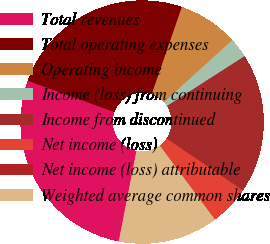Convert chart. <chart><loc_0><loc_0><loc_500><loc_500><pie_chart><fcel>Total revenues<fcel>Total operating expenses<fcel>Operating income<fcel>Income (loss) from continuing<fcel>Income from discontinued<fcel>Net income (loss)<fcel>Net income (loss) attributable<fcel>Weighted average common shares<nl><fcel>27.43%<fcel>24.78%<fcel>7.96%<fcel>2.65%<fcel>18.58%<fcel>5.31%<fcel>0.0%<fcel>13.27%<nl></chart> 